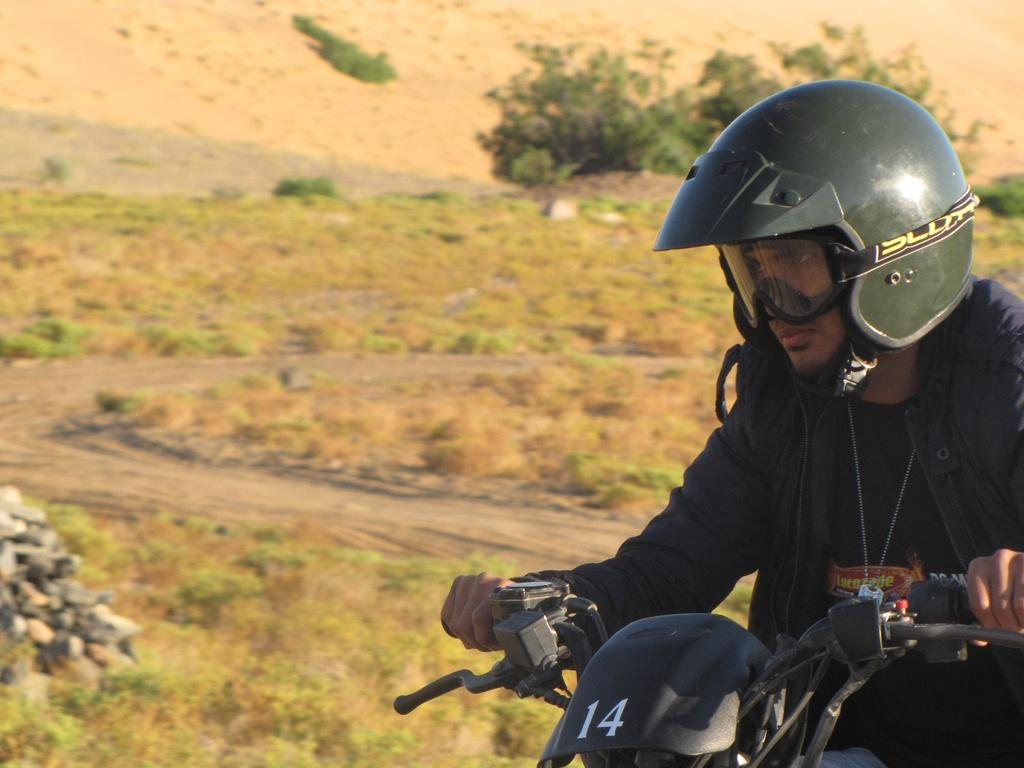What is the person in the image doing? The person is sitting on a bike. What safety gear is the person wearing? The person is wearing a helmet. What type of clothing is the person wearing? The person is wearing a jacket. What type of surface is visible in the image? The ground is visible in the image, and it is covered with grass. What can be seen in the background of the image? There are trees visible in the background of the image. What type of treatment is the person receiving for their ice-related injuries in the image? There is no indication of any ice-related injuries or treatment in the image. 